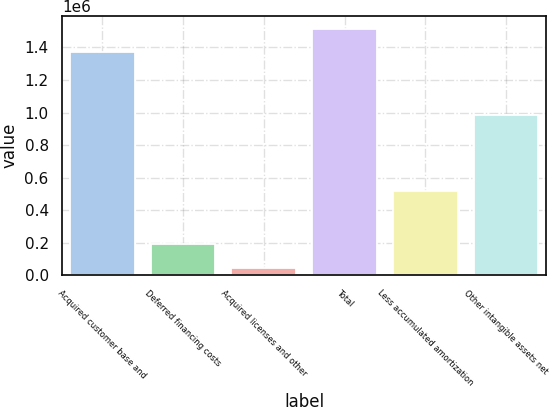Convert chart. <chart><loc_0><loc_0><loc_500><loc_500><bar_chart><fcel>Acquired customer base and<fcel>Deferred financing costs<fcel>Acquired licenses and other<fcel>Total<fcel>Less accumulated amortization<fcel>Other intangible assets net<nl><fcel>1.36961e+06<fcel>189338<fcel>43404<fcel>1.51554e+06<fcel>517444<fcel>985303<nl></chart> 